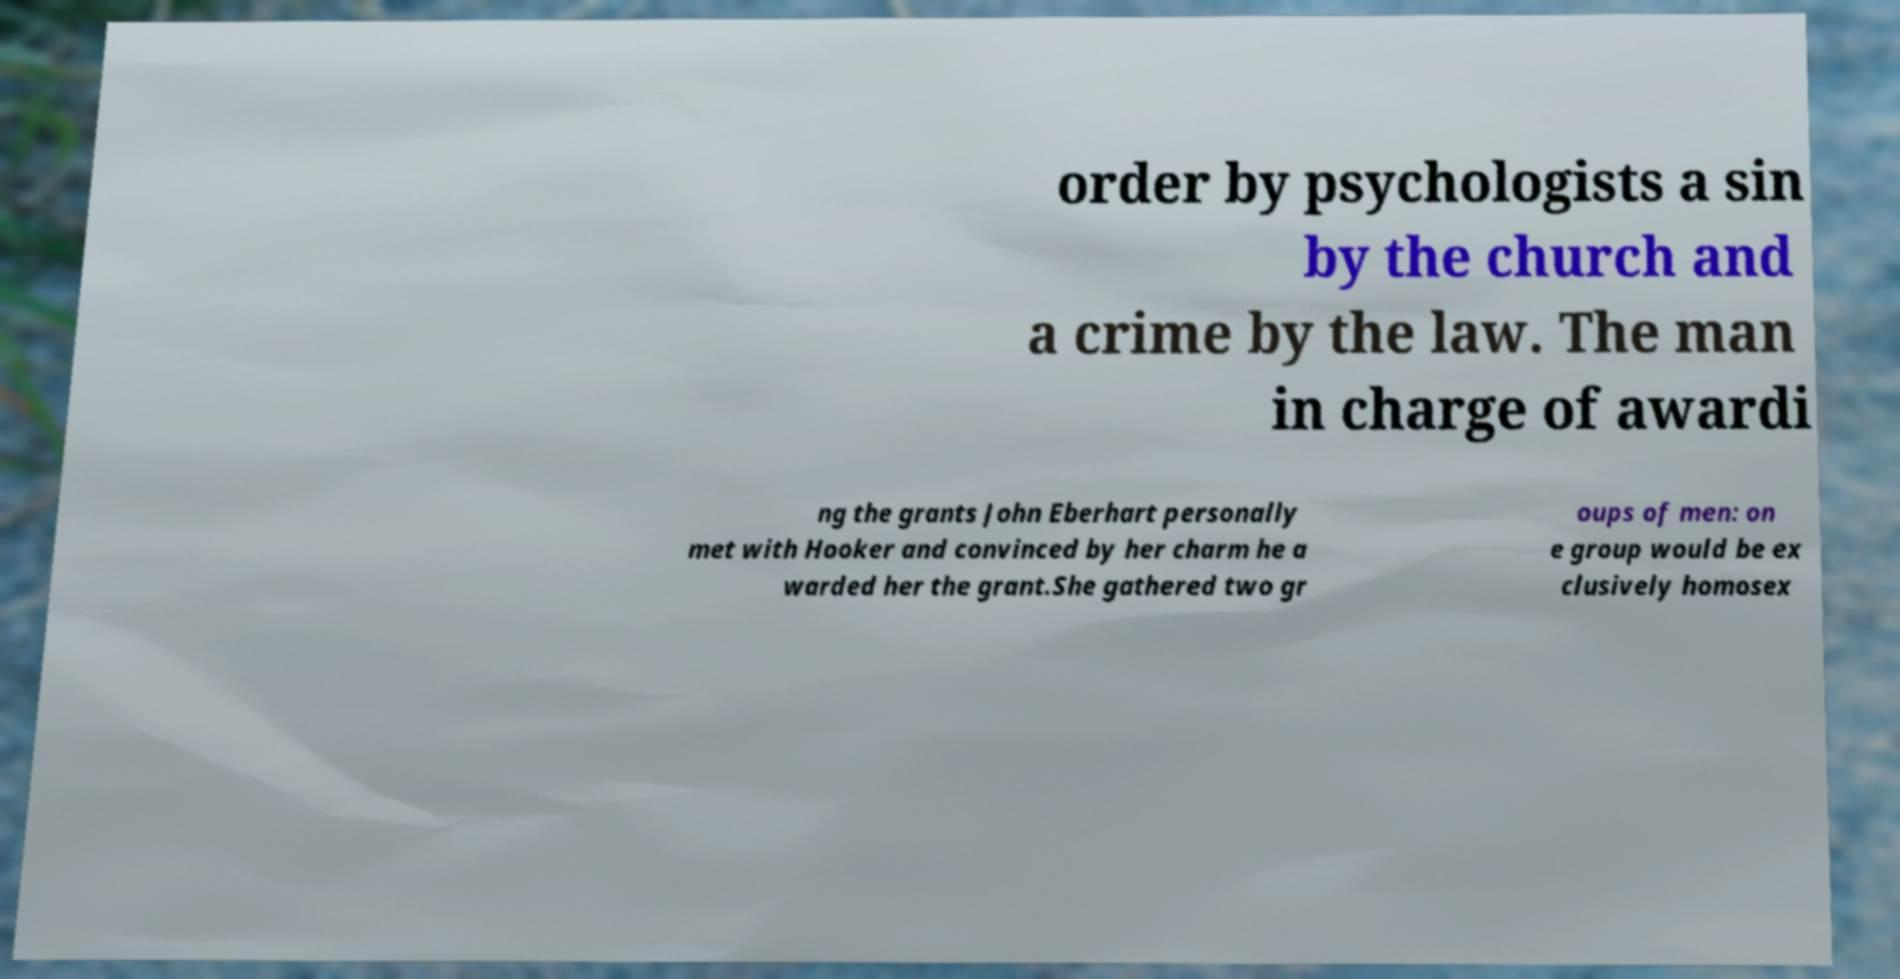Please identify and transcribe the text found in this image. order by psychologists a sin by the church and a crime by the law. The man in charge of awardi ng the grants John Eberhart personally met with Hooker and convinced by her charm he a warded her the grant.She gathered two gr oups of men: on e group would be ex clusively homosex 